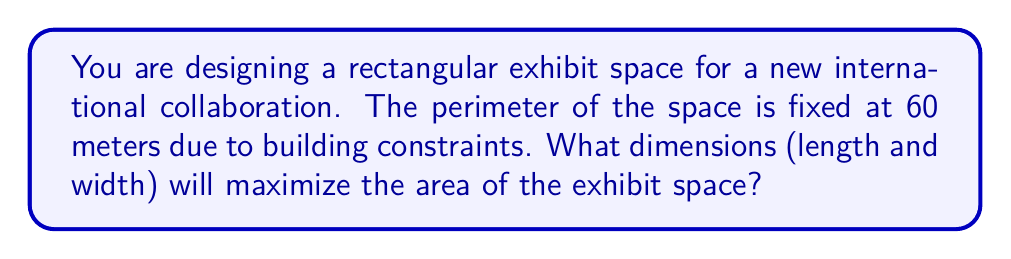Could you help me with this problem? Let's approach this step-by-step:

1) Let $l$ be the length and $w$ be the width of the rectangular space.

2) Given that the perimeter is 60 meters, we can write:
   $$2l + 2w = 60$$

3) Solving for $l$:
   $$l = 30 - w$$

4) The area $A$ of a rectangle is given by $A = lw$. Substituting our expression for $l$:
   $$A = w(30 - w) = 30w - w^2$$

5) To find the maximum area, we need to find the vertex of this quadratic function. We can do this by finding where the derivative equals zero:
   $$\frac{dA}{dw} = 30 - 2w$$

6) Setting this equal to zero:
   $$30 - 2w = 0$$
   $$2w = 30$$
   $$w = 15$$

7) Since the second derivative $\frac{d^2A}{dw^2} = -2$ is negative, this critical point is a maximum.

8) If $w = 15$, then $l = 30 - 15 = 15$ as well.

9) Therefore, the exhibit space should be a square with sides of 15 meters each.

10) We can verify that this satisfies our perimeter constraint:
    $$2(15) + 2(15) = 60$$

11) The maximum area will be:
    $$A = 15 * 15 = 225\text{ square meters}$$
Answer: 15 m × 15 m 